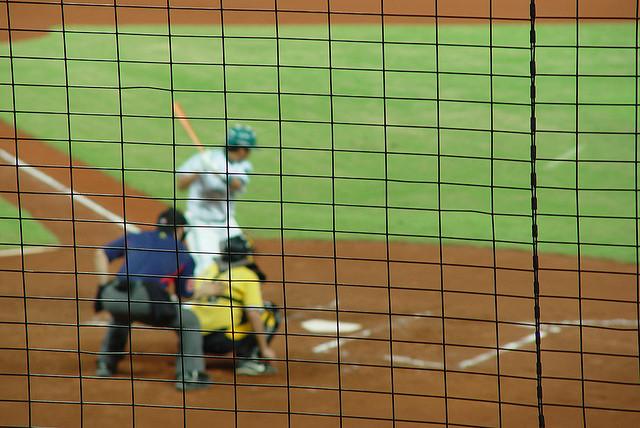Has the batter begun to swing?
Quick response, please. No. What are the names of the teams?
Write a very short answer. Orioles and braves. What color is the catchers shirt?
Quick response, please. Yellow. 